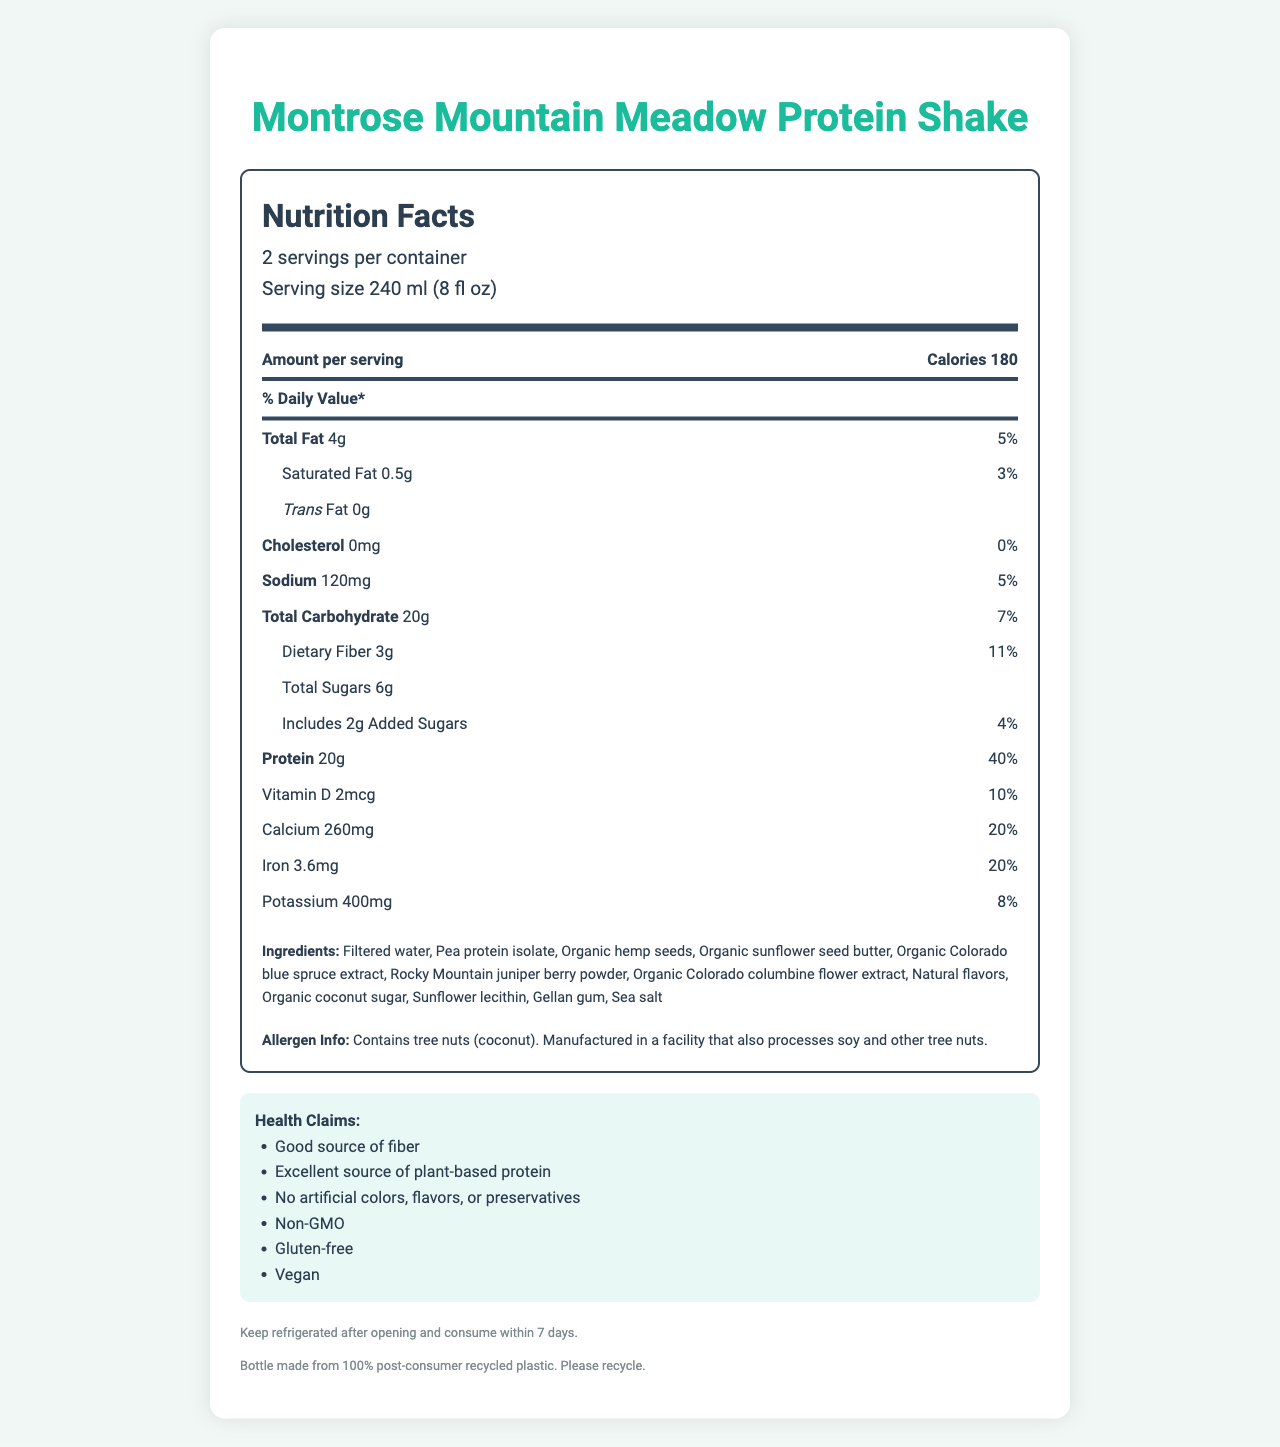what is the serving size? The serving size is mentioned under the "serving info" section of the nutrition label, which states "Serving size 240 ml (8 fl oz)".
Answer: 240 ml (8 fl oz) how many calories are in one serving? The "Amount per serving" section shows the calorie content, which is stated as 180 calories.
Answer: 180 calories what percentage of daily value is the protein content per serving? Under the protein section, it lists 20g of protein and 40% of the daily value.
Answer: 40% how much dietary fiber is in one serving? The dietary fiber content is listed with a value of 3g in the "Total Carbohydrate" section.
Answer: 3g what are the main sources of protein in the shake? According to the ingredients list, the main sources of protein are pea protein isolate, organic hemp seeds, and organic sunflower seed butter.
Answer: Pea protein isolate, Organic hemp seeds, Organic sunflower seed butter how much sugar has been added to the shake? The "Includes 2g Added Sugars" section in the label shows the added sugar content.
Answer: 2g how many servings are there per container? The serving information at the top indicates there are 2 servings per container.
Answer: 2 servings what are the health claims associated with this shake? A. Good source of protein B. Gluten-free C. Contains artificial flavors D. High in cholesterol The health claims list states "Gluten-free" along with other claims, but not "Contains artificial flavors" or "High in cholesterol".
Answer: B which vitamin is included in the shake and at what amount? A. Vitamin A - 3mcg B. Vitamin D - 2mcg C. Vitamin C - 5mcg D. Vitamin B12 - 1mcg The nutrition facts include Vitamin D with an amount of 2mcg.
Answer: B is this product suitable for vegans? The health claims section explicitly states that the product is vegan.
Answer: Yes can you list all the ingredients in the protein shake? The ingredients are listed in the document under the "Ingredients" section.
Answer: Filtered water, Pea protein isolate, Organic hemp seeds, Organic sunflower seed butter, Organic Colorado blue spruce extract, Rocky Mountain juniper berry powder, Organic Colorado columbine flower extract, Natural flavors, Organic coconut sugar, Sunflower lecithin, Gellan gum, Sea salt why might this shake be a good option for someone looking to increase their calcium intake? The nutrition facts label states that each serving of the shake has 260mg of calcium, which is 20% of the daily value, making it a good option for increasing calcium intake.
Answer: It contains 20% of the daily value of calcium per serving what is the storage requirement after opening the shake? The footer section of the document mentions to keep the product refrigerated after opening and consume it within 7 days.
Answer: Keep refrigerated and consume within 7 days is the bottle recyclable? The footer of the document states that the bottle is made from 100% post-consumer recycled plastic and should be recycled.
Answer: Yes what is the main focus of this document? The document's main focus is to inform consumers about the nutritional content, ingredients, health benefits, storage, and recycling information for the product.
Answer: The document provides detailed nutrition facts, ingredient information, health claims, and storage and recycling instructions for the Montrose Mountain Meadow Protein Shake. what is the source of the ingredients inspired by? The document mentions ingredients inspired by local flora like Organic Colorado blue spruce extract and Rocky Mountain juniper berry powder, but it does not explicitly state their sources or inspiration clearly.
Answer: Cannot be determined 